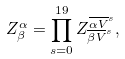<formula> <loc_0><loc_0><loc_500><loc_500>Z ^ { \alpha } _ { \beta } = \prod _ { s = 0 } ^ { 1 9 } Z ^ { { \overline { \alpha V } } ^ { s } } _ { { \overline { \beta V } } ^ { s } } ,</formula> 